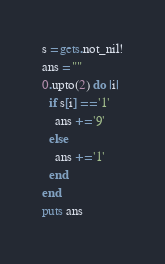<code> <loc_0><loc_0><loc_500><loc_500><_Crystal_>s = gets.not_nil!
ans = ""
0.upto(2) do |i|
  if s[i] == '1'
    ans += '9'
  else
    ans += '1'
  end
end
puts ans</code> 